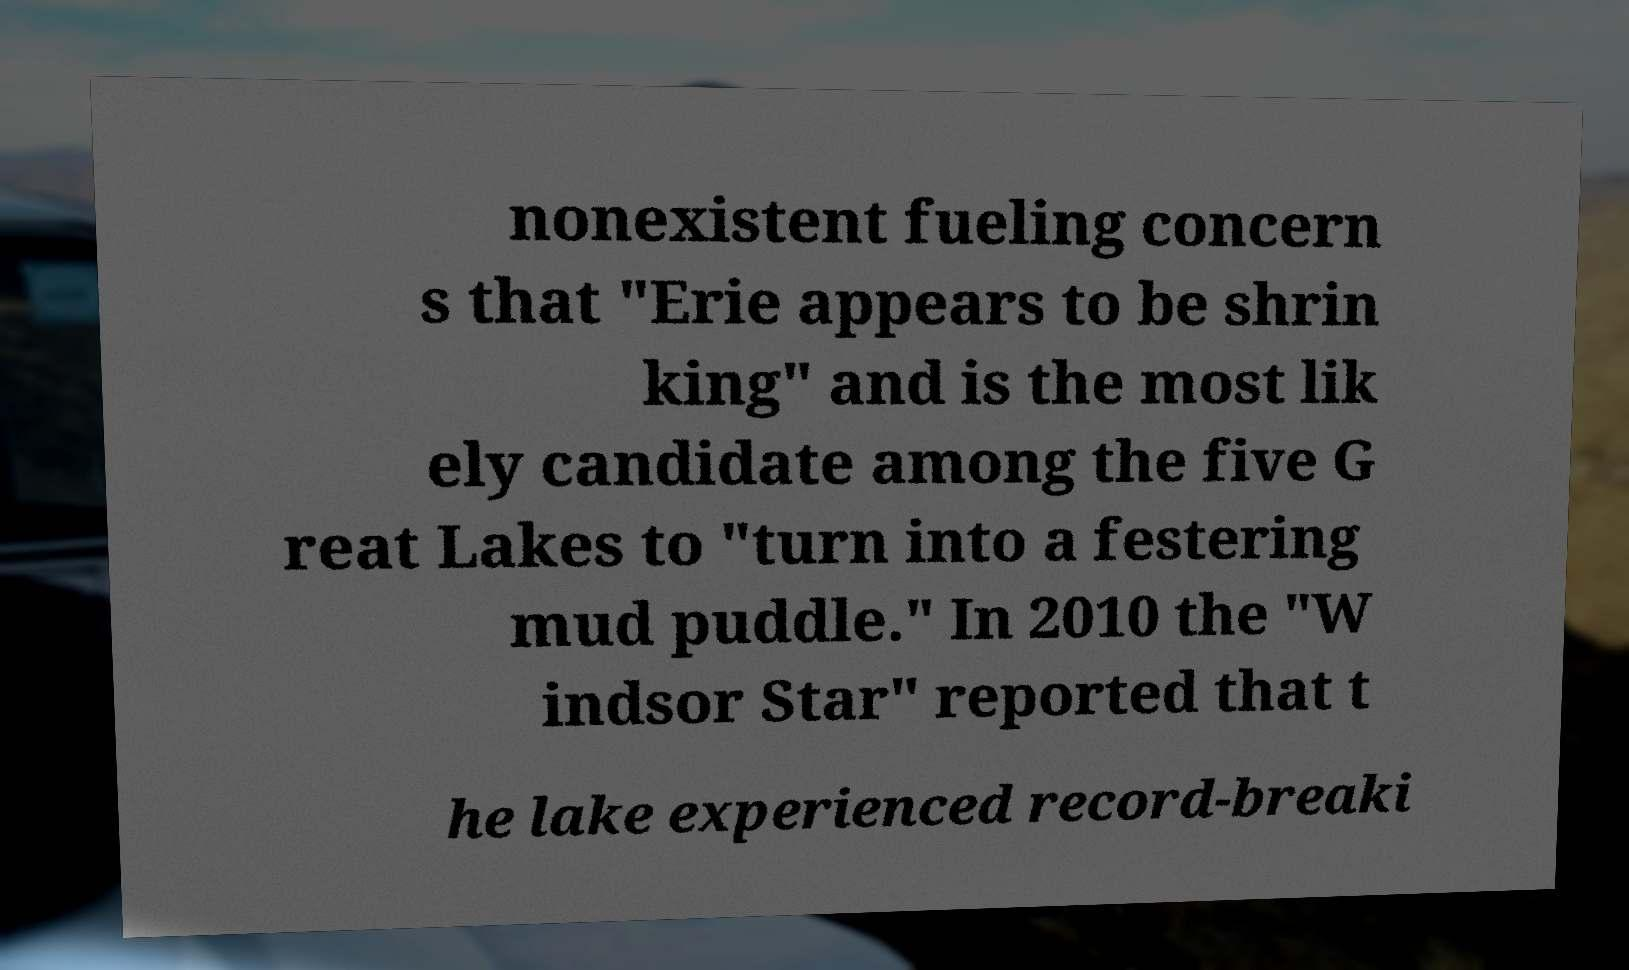Please identify and transcribe the text found in this image. nonexistent fueling concern s that "Erie appears to be shrin king" and is the most lik ely candidate among the five G reat Lakes to "turn into a festering mud puddle." In 2010 the "W indsor Star" reported that t he lake experienced record-breaki 